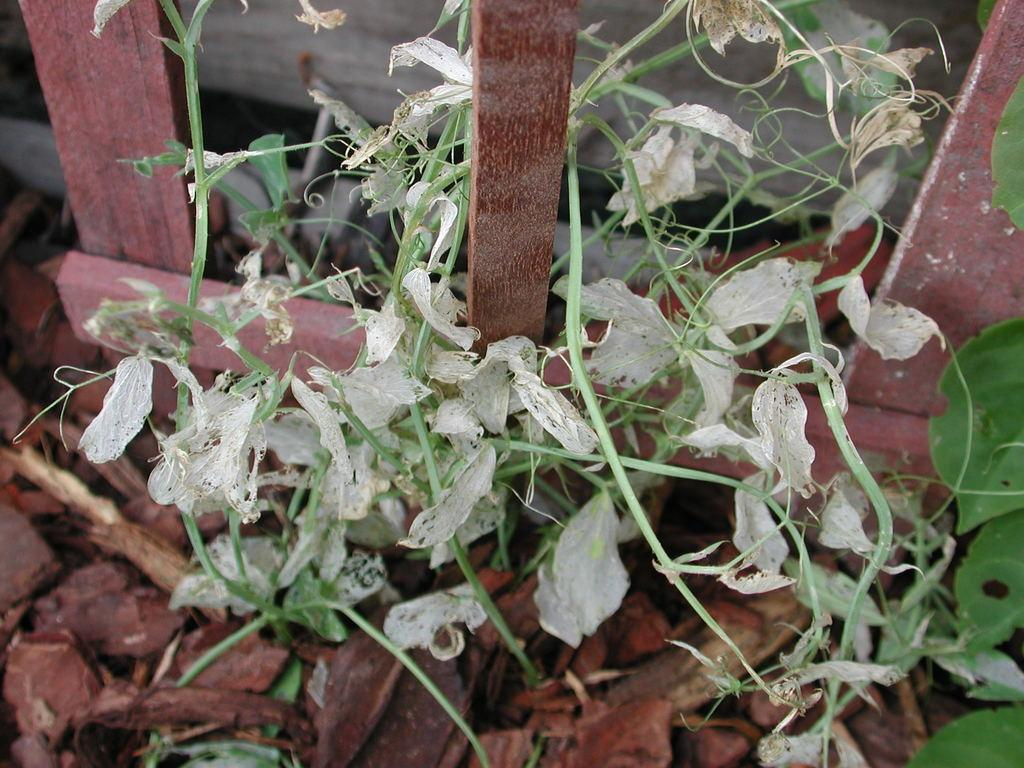What type of plants are in the image? There are flowers in the image. What part of the flowers can be seen in the image? The flowers have stems in the image. How are the flowers arranged or supported in the image? The flowers are around wooden sticks in the image. What type of force is being applied to the flowers in the image? There is no indication of any force being applied to the flowers in the image. 